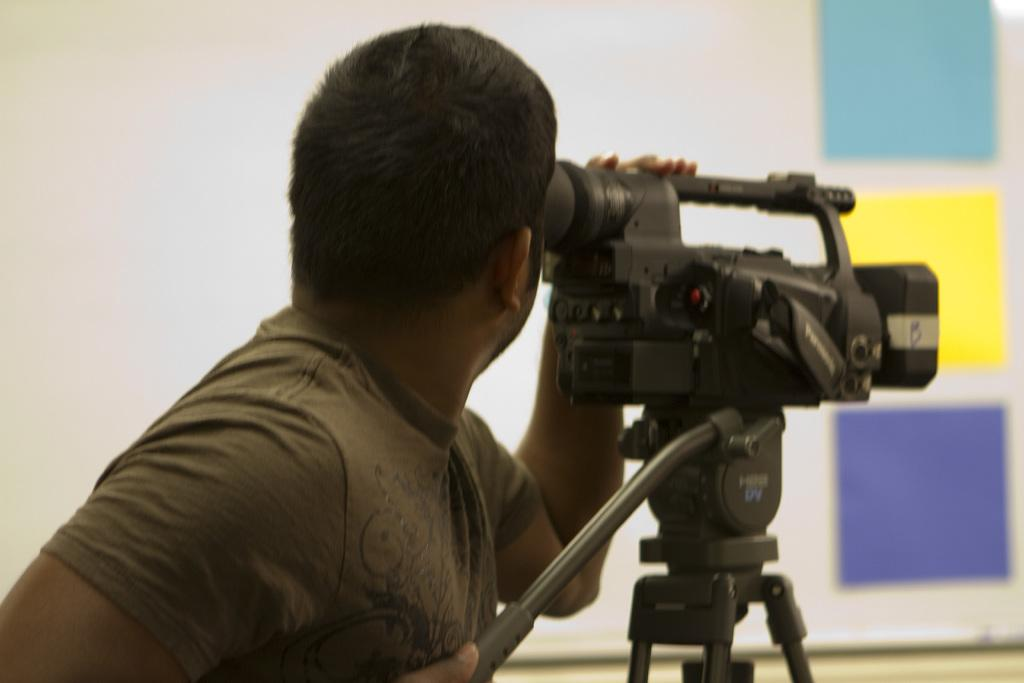What is the main subject of the image? There is a man standing in the image. What is located in front of the man? There is a camera on a tripod stand in front of the man. What can be seen in the background of the image? There is a wall in the background of the image. What type of toothpaste is the man using in the image? There is no toothpaste present in the image. Is the man wearing a mask in the image? There is no mention of a mask in the image, and the man's face is visible. 